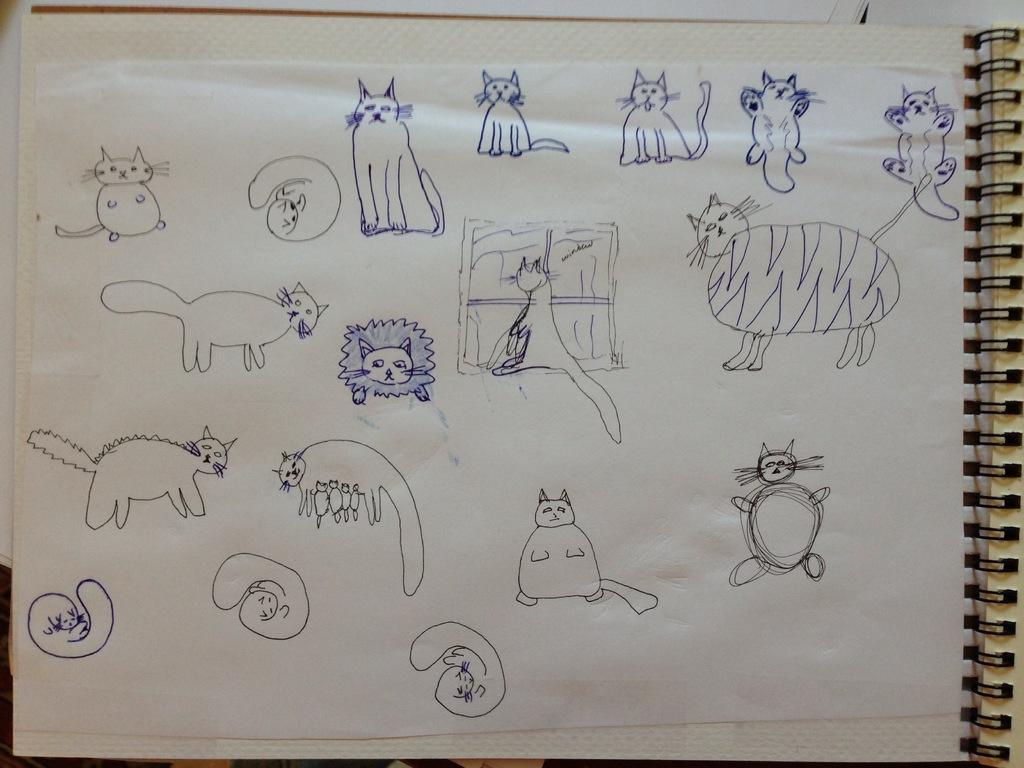Describe this image in one or two sentences. In this image I can see a paper of a scribbling pad on which various cat images are drawn by a pen. 